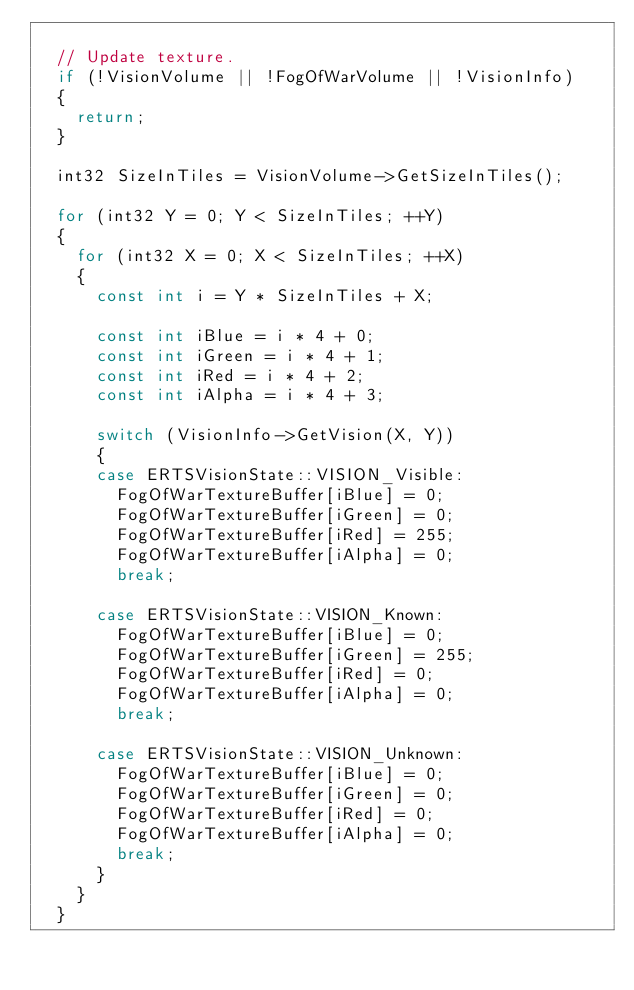<code> <loc_0><loc_0><loc_500><loc_500><_C++_>
	// Update texture.
	if (!VisionVolume || !FogOfWarVolume || !VisionInfo)
	{
		return;
	}

	int32 SizeInTiles = VisionVolume->GetSizeInTiles();

	for (int32 Y = 0; Y < SizeInTiles; ++Y)
	{
		for (int32 X = 0; X < SizeInTiles; ++X)
		{
			const int i = Y * SizeInTiles + X;

			const int iBlue = i * 4 + 0;
			const int iGreen = i * 4 + 1;
			const int iRed = i * 4 + 2;
			const int iAlpha = i * 4 + 3;

			switch (VisionInfo->GetVision(X, Y))
			{
			case ERTSVisionState::VISION_Visible:
				FogOfWarTextureBuffer[iBlue] = 0;
				FogOfWarTextureBuffer[iGreen] = 0;
				FogOfWarTextureBuffer[iRed] = 255;
				FogOfWarTextureBuffer[iAlpha] = 0;
				break;

			case ERTSVisionState::VISION_Known:
				FogOfWarTextureBuffer[iBlue] = 0;
				FogOfWarTextureBuffer[iGreen] = 255;
				FogOfWarTextureBuffer[iRed] = 0;
				FogOfWarTextureBuffer[iAlpha] = 0;
				break;

			case ERTSVisionState::VISION_Unknown:
				FogOfWarTextureBuffer[iBlue] = 0;
				FogOfWarTextureBuffer[iGreen] = 0;
				FogOfWarTextureBuffer[iRed] = 0;
				FogOfWarTextureBuffer[iAlpha] = 0;
				break;
			}
		}
	}
</code> 